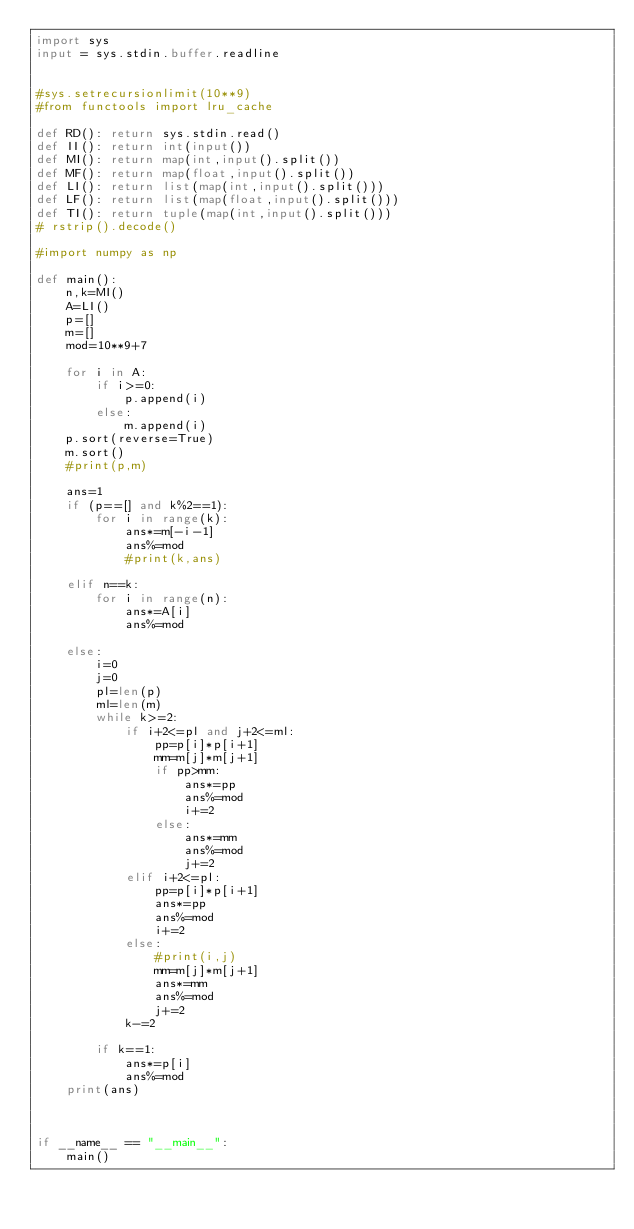Convert code to text. <code><loc_0><loc_0><loc_500><loc_500><_Python_>import sys
input = sys.stdin.buffer.readline


#sys.setrecursionlimit(10**9)
#from functools import lru_cache

def RD(): return sys.stdin.read()
def II(): return int(input())
def MI(): return map(int,input().split())
def MF(): return map(float,input().split())
def LI(): return list(map(int,input().split()))
def LF(): return list(map(float,input().split()))
def TI(): return tuple(map(int,input().split()))
# rstrip().decode()

#import numpy as np

def main():
	n,k=MI()
	A=LI()
	p=[]
	m=[]
	mod=10**9+7

	for i in A:
		if i>=0:
			p.append(i)
		else:
			m.append(i)
	p.sort(reverse=True)
	m.sort()
	#print(p,m)

	ans=1
	if (p==[] and k%2==1):
		for i in range(k):
			ans*=m[-i-1]
			ans%=mod
			#print(k,ans)

	elif n==k:
		for i in range(n):
			ans*=A[i]
			ans%=mod

	else:
		i=0
		j=0
		pl=len(p)
		ml=len(m)
		while k>=2:
			if i+2<=pl and j+2<=ml:
				pp=p[i]*p[i+1]
				mm=m[j]*m[j+1]
				if pp>mm:
					ans*=pp
					ans%=mod
					i+=2
				else:
					ans*=mm
					ans%=mod
					j+=2
			elif i+2<=pl:
				pp=p[i]*p[i+1]
				ans*=pp
				ans%=mod
				i+=2
			else:
				#print(i,j)
				mm=m[j]*m[j+1]
				ans*=mm
				ans%=mod
				j+=2
			k-=2

		if k==1:
			ans*=p[i]
			ans%=mod
	print(ans)



if __name__ == "__main__":
	main()
</code> 